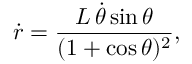<formula> <loc_0><loc_0><loc_500><loc_500>\dot { r } = \frac { L \, \dot { \theta } \sin \theta } { ( 1 + \cos \theta ) ^ { 2 } } ,</formula> 